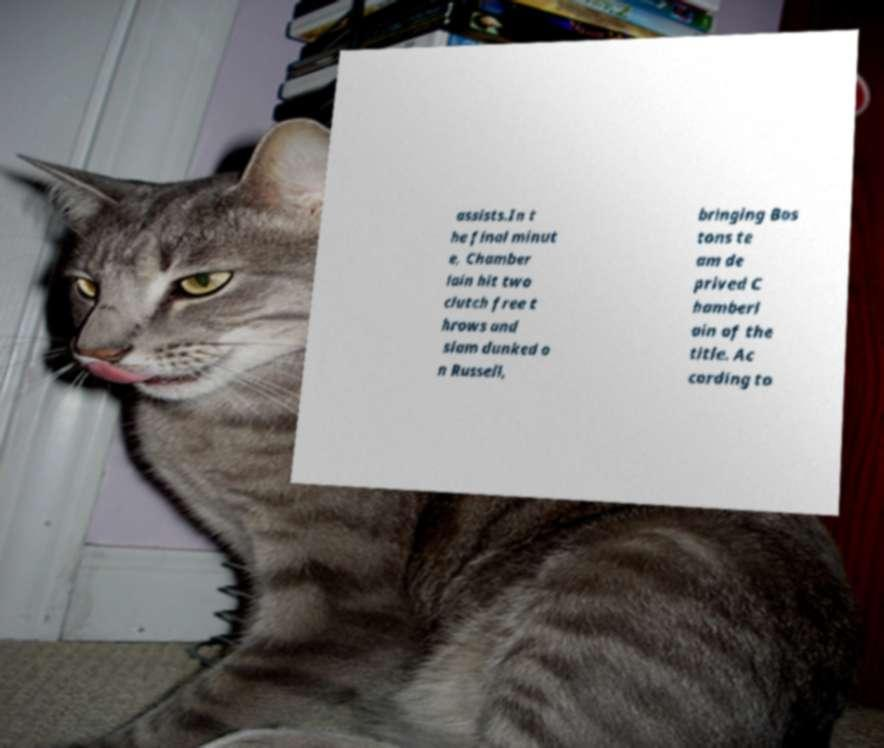Could you extract and type out the text from this image? assists.In t he final minut e, Chamber lain hit two clutch free t hrows and slam dunked o n Russell, bringing Bos tons te am de prived C hamberl ain of the title. Ac cording to 